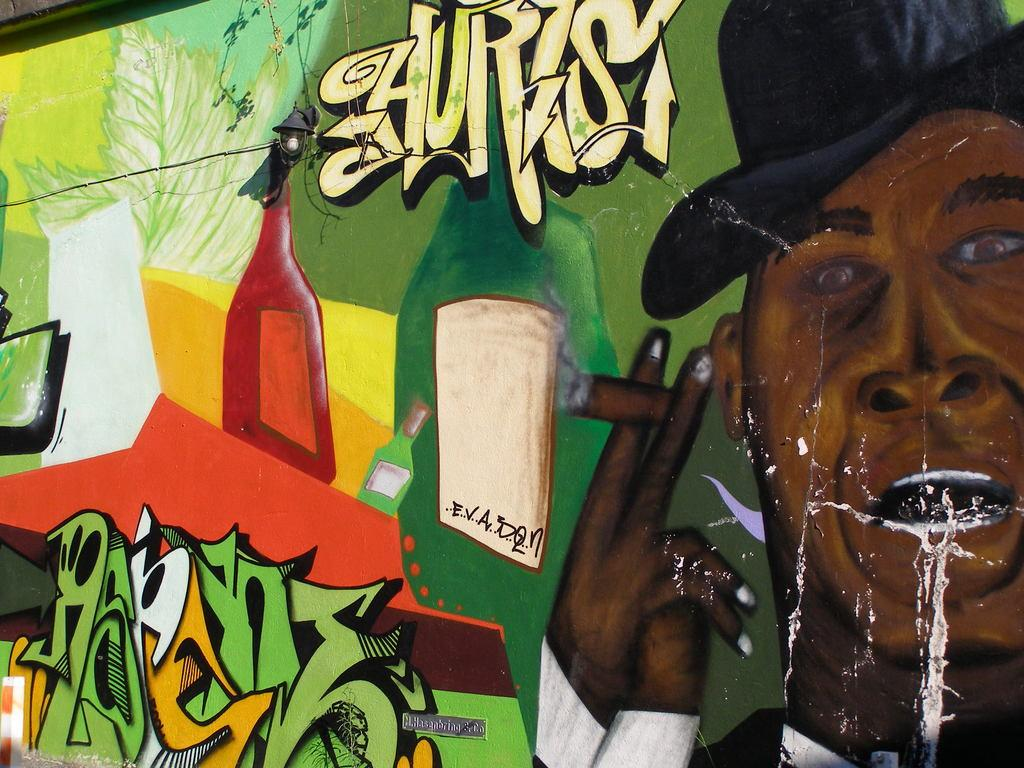What is located in the center of the image? There is a wall in the center of the image. What is on the wall? There is a painting on the wall. What is depicted in the painting? The painting contains a human face and bottles. What type of cave can be seen in the background of the painting? There is no cave present in the image or the painting. 